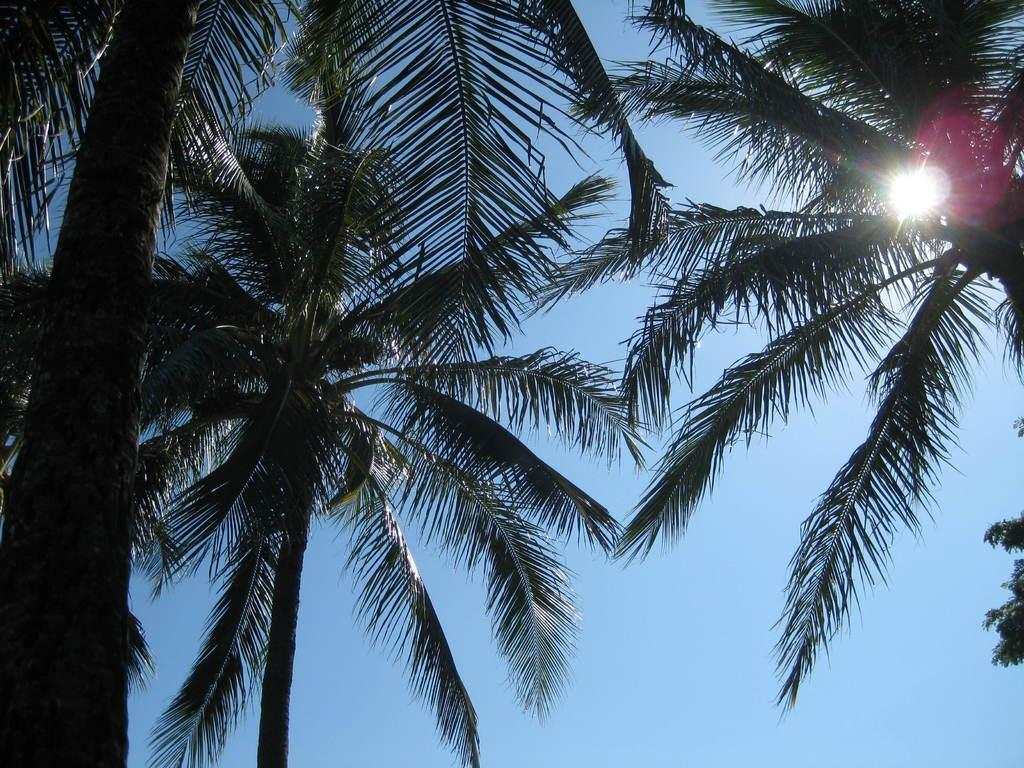What is the setting of the image? The image has an outside view. What can be seen in the foreground of the image? There are trees in the foreground of the image. What is visible in the background of the image? The sky is visible in the background of the image. How many cows can be seen in the image? There are no cows present in the image. What color are the eyes of the trees in the image? Trees do not have eyes, so this question cannot be answered. 